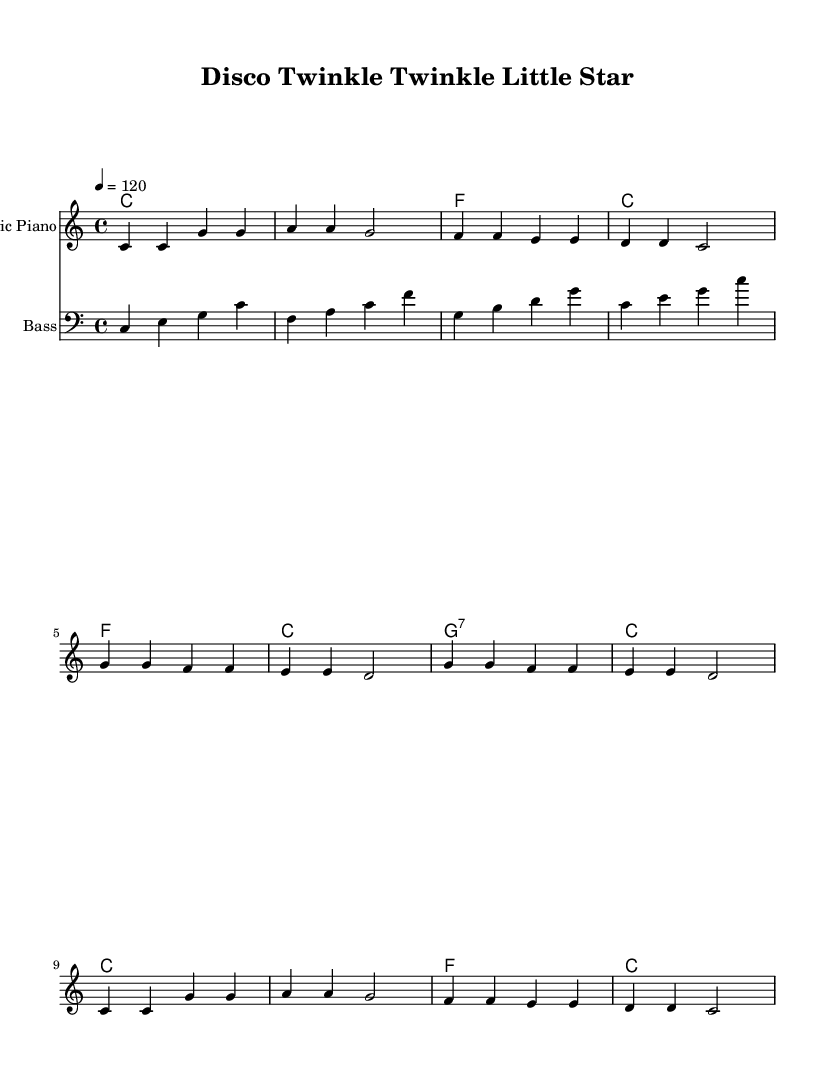What is the key signature of this music? The key signature is determined by looking at the information in the header notation, which shows 'c' indicating that the piece is in C major. C major has no sharps or flats.
Answer: C major What is the time signature of the music? The time signature is shown at the beginning of the staff notation. It is represented as '4/4', which indicates that there are four beats in each measure and that the quarter note receives one beat.
Answer: 4/4 What is the tempo marking in the music? The tempo marking is indicated as '4 = 120', which means there are 120 beats per minute, and the quarter note is the beat.
Answer: 120 How many measures are in the melody section? By counting the groups of notes divided by vertical lines (bars) in the melody, there are 8 measures total.
Answer: 8 What instrument is specified for the melody? The instrument name is provided in the staff with 'Electric Piano,' indicating that this is the intended instrument for the melody part of the score.
Answer: Electric Piano What chord appears most frequently in the harmony section? By analyzing the chord sequence written in the harmony section, 'C' appears at the beginning of several measures, indicating it is the most common chord.
Answer: C What style of music does this piece represent? The general feel of the arrangement, coupled with the title 'Disco Twinkle Twinkle Little Star,' indicates that the piece is a disco remix version of a classic children's song.
Answer: Disco 